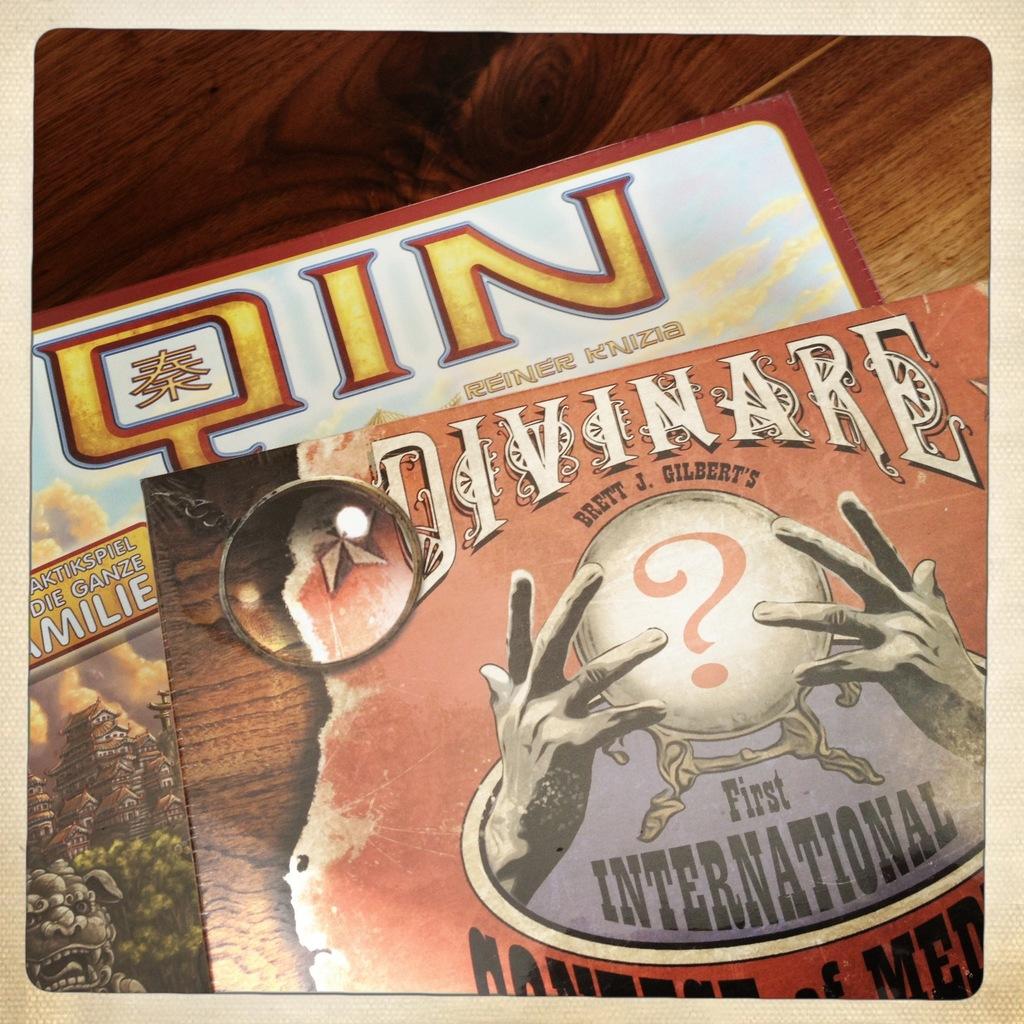What is this first of?
Offer a very short reply. International. What three letters at top?
Give a very brief answer. Qin. 